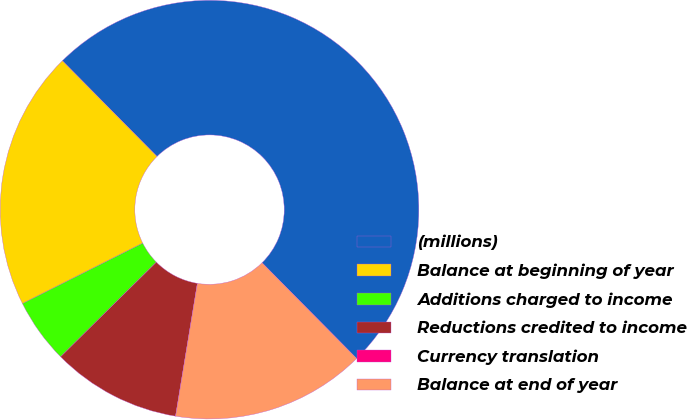Convert chart to OTSL. <chart><loc_0><loc_0><loc_500><loc_500><pie_chart><fcel>(millions)<fcel>Balance at beginning of year<fcel>Additions charged to income<fcel>Reductions credited to income<fcel>Currency translation<fcel>Balance at end of year<nl><fcel>50.0%<fcel>20.0%<fcel>5.0%<fcel>10.0%<fcel>0.0%<fcel>15.0%<nl></chart> 